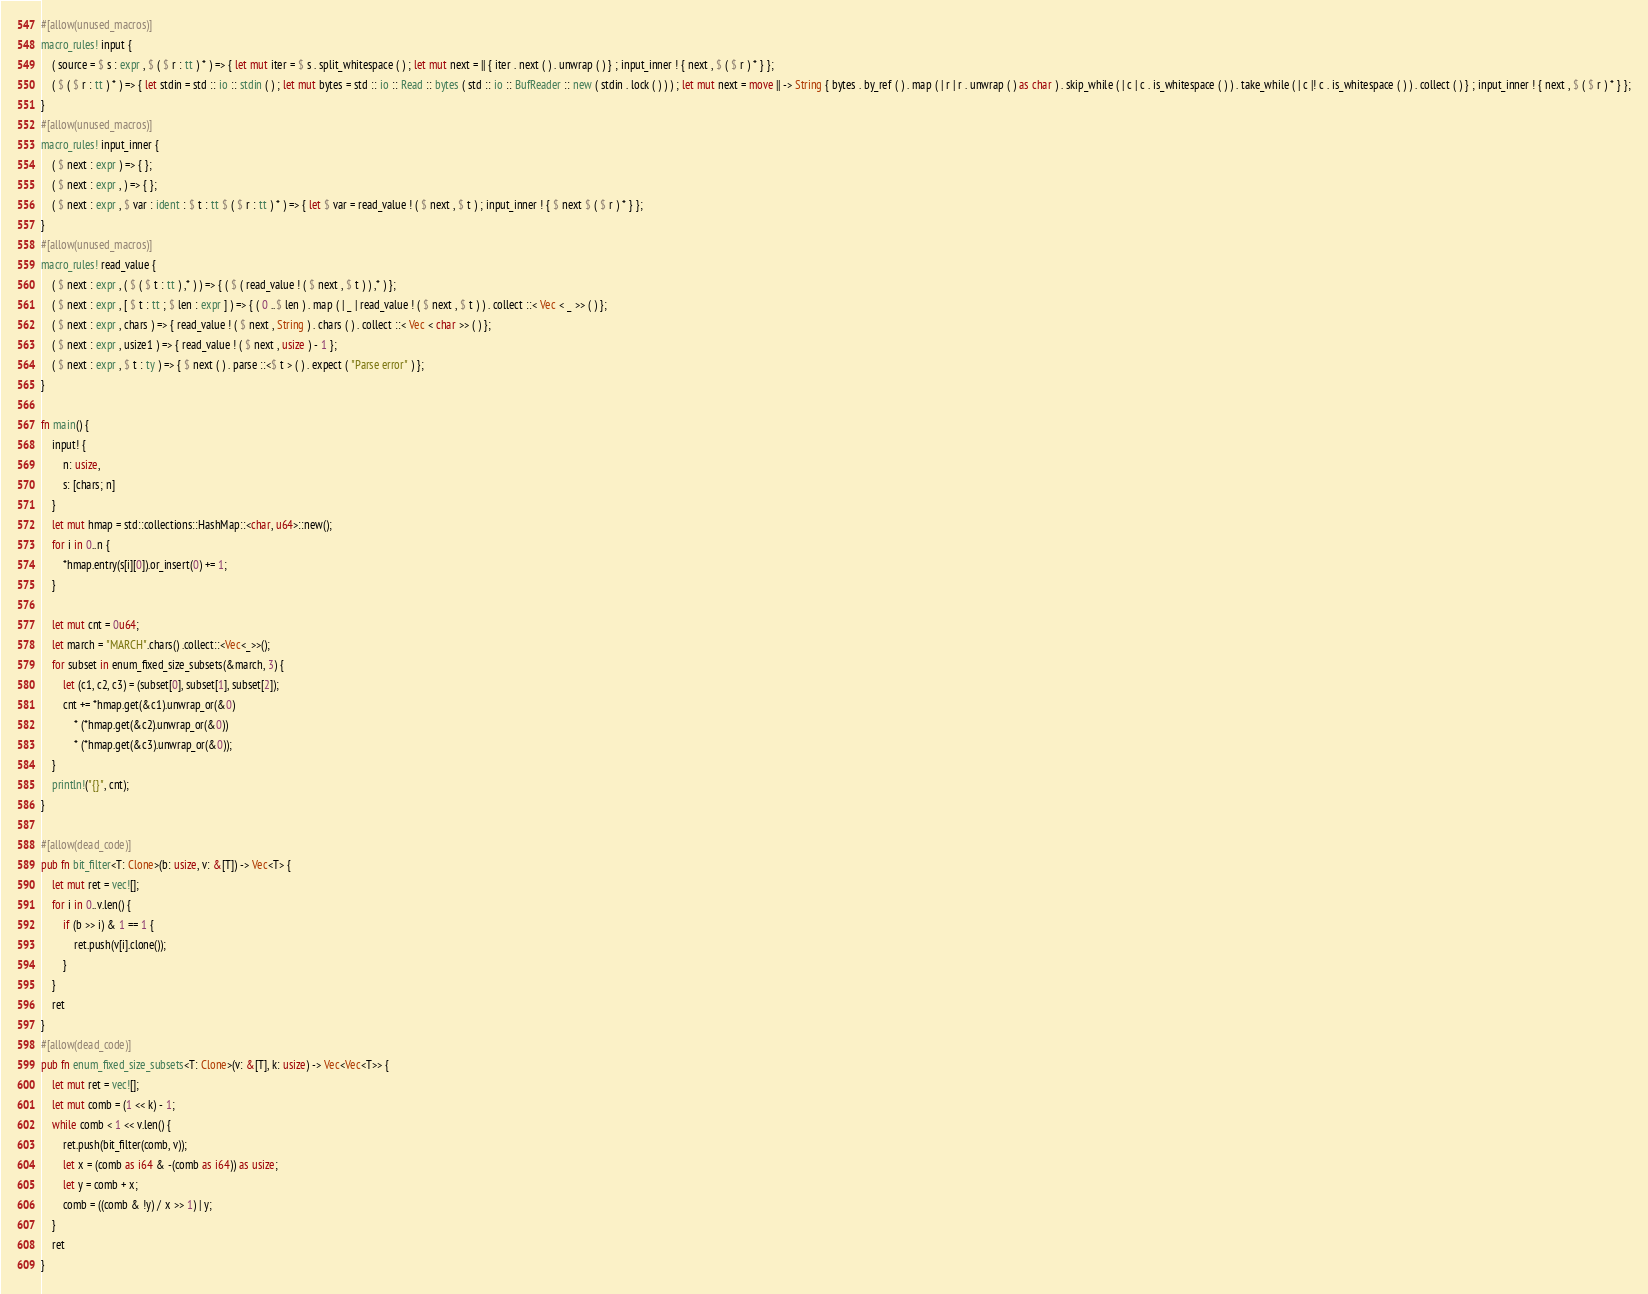Convert code to text. <code><loc_0><loc_0><loc_500><loc_500><_Rust_>#[allow(unused_macros)]
macro_rules! input {
    ( source = $ s : expr , $ ( $ r : tt ) * ) => { let mut iter = $ s . split_whitespace ( ) ; let mut next = || { iter . next ( ) . unwrap ( ) } ; input_inner ! { next , $ ( $ r ) * } };
    ( $ ( $ r : tt ) * ) => { let stdin = std :: io :: stdin ( ) ; let mut bytes = std :: io :: Read :: bytes ( std :: io :: BufReader :: new ( stdin . lock ( ) ) ) ; let mut next = move || -> String { bytes . by_ref ( ) . map ( | r | r . unwrap ( ) as char ) . skip_while ( | c | c . is_whitespace ( ) ) . take_while ( | c |! c . is_whitespace ( ) ) . collect ( ) } ; input_inner ! { next , $ ( $ r ) * } };
}
#[allow(unused_macros)]
macro_rules! input_inner {
    ( $ next : expr ) => { };
    ( $ next : expr , ) => { };
    ( $ next : expr , $ var : ident : $ t : tt $ ( $ r : tt ) * ) => { let $ var = read_value ! ( $ next , $ t ) ; input_inner ! { $ next $ ( $ r ) * } };
}
#[allow(unused_macros)]
macro_rules! read_value {
    ( $ next : expr , ( $ ( $ t : tt ) ,* ) ) => { ( $ ( read_value ! ( $ next , $ t ) ) ,* ) };
    ( $ next : expr , [ $ t : tt ; $ len : expr ] ) => { ( 0 ..$ len ) . map ( | _ | read_value ! ( $ next , $ t ) ) . collect ::< Vec < _ >> ( ) };
    ( $ next : expr , chars ) => { read_value ! ( $ next , String ) . chars ( ) . collect ::< Vec < char >> ( ) };
    ( $ next : expr , usize1 ) => { read_value ! ( $ next , usize ) - 1 };
    ( $ next : expr , $ t : ty ) => { $ next ( ) . parse ::<$ t > ( ) . expect ( "Parse error" ) };
}

fn main() {
    input! {
        n: usize,
        s: [chars; n]
    }
    let mut hmap = std::collections::HashMap::<char, u64>::new();
    for i in 0..n {
        *hmap.entry(s[i][0]).or_insert(0) += 1;
    }

    let mut cnt = 0u64;
    let march = "MARCH".chars() .collect::<Vec<_>>();
    for subset in enum_fixed_size_subsets(&march, 3) {
        let (c1, c2, c3) = (subset[0], subset[1], subset[2]);
        cnt += *hmap.get(&c1).unwrap_or(&0)
            * (*hmap.get(&c2).unwrap_or(&0))
            * (*hmap.get(&c3).unwrap_or(&0));
    }
    println!("{}", cnt);
}

#[allow(dead_code)]
pub fn bit_filter<T: Clone>(b: usize, v: &[T]) -> Vec<T> {
    let mut ret = vec![];
    for i in 0..v.len() {
        if (b >> i) & 1 == 1 {
            ret.push(v[i].clone());
        }
    }
    ret
}
#[allow(dead_code)]
pub fn enum_fixed_size_subsets<T: Clone>(v: &[T], k: usize) -> Vec<Vec<T>> {
    let mut ret = vec![];
    let mut comb = (1 << k) - 1;
    while comb < 1 << v.len() {
        ret.push(bit_filter(comb, v));
        let x = (comb as i64 & -(comb as i64)) as usize;
        let y = comb + x;
        comb = ((comb & !y) / x >> 1) | y;
    }
    ret
}</code> 